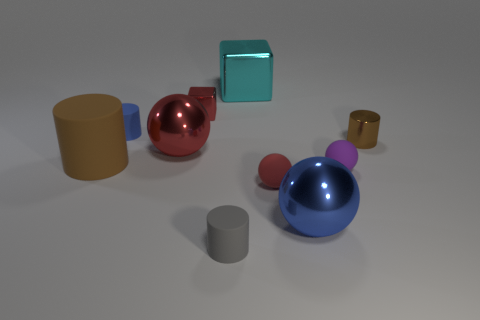Subtract 1 balls. How many balls are left? 3 Subtract all cylinders. How many objects are left? 6 Subtract all gray metallic cylinders. Subtract all small rubber cylinders. How many objects are left? 8 Add 2 tiny gray cylinders. How many tiny gray cylinders are left? 3 Add 2 tiny things. How many tiny things exist? 8 Subtract 0 blue blocks. How many objects are left? 10 